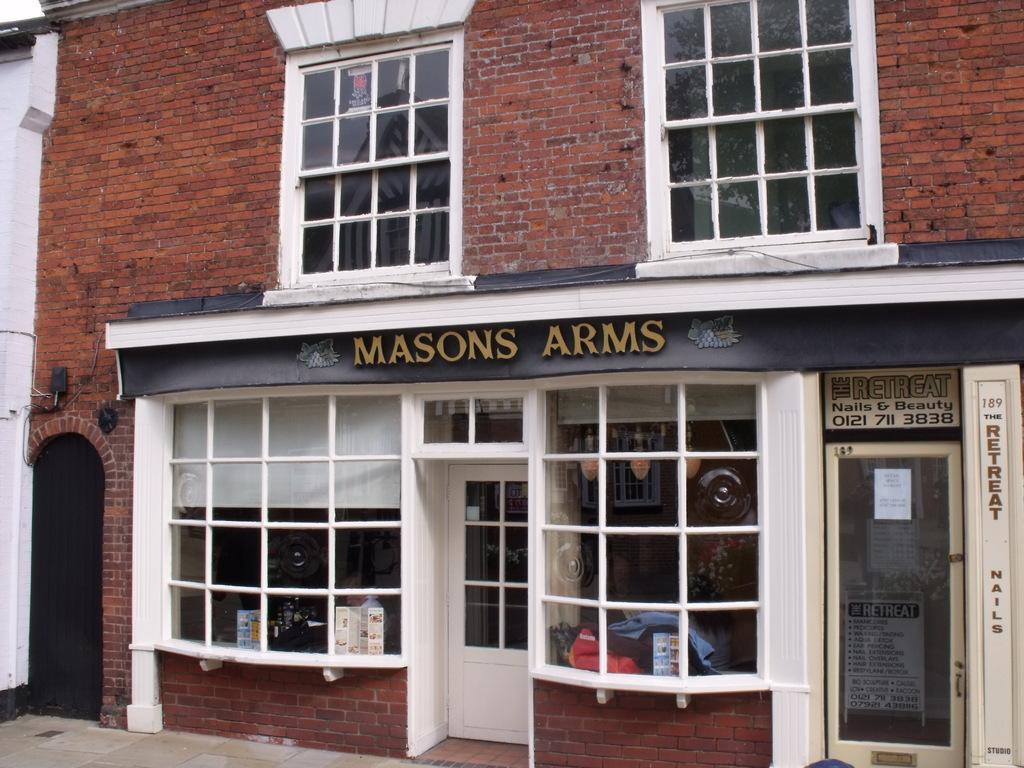Please provide a concise description of this image. In this image there is a building with the windows in the middle. Below the building there is a house with the two doors and glass windows. 